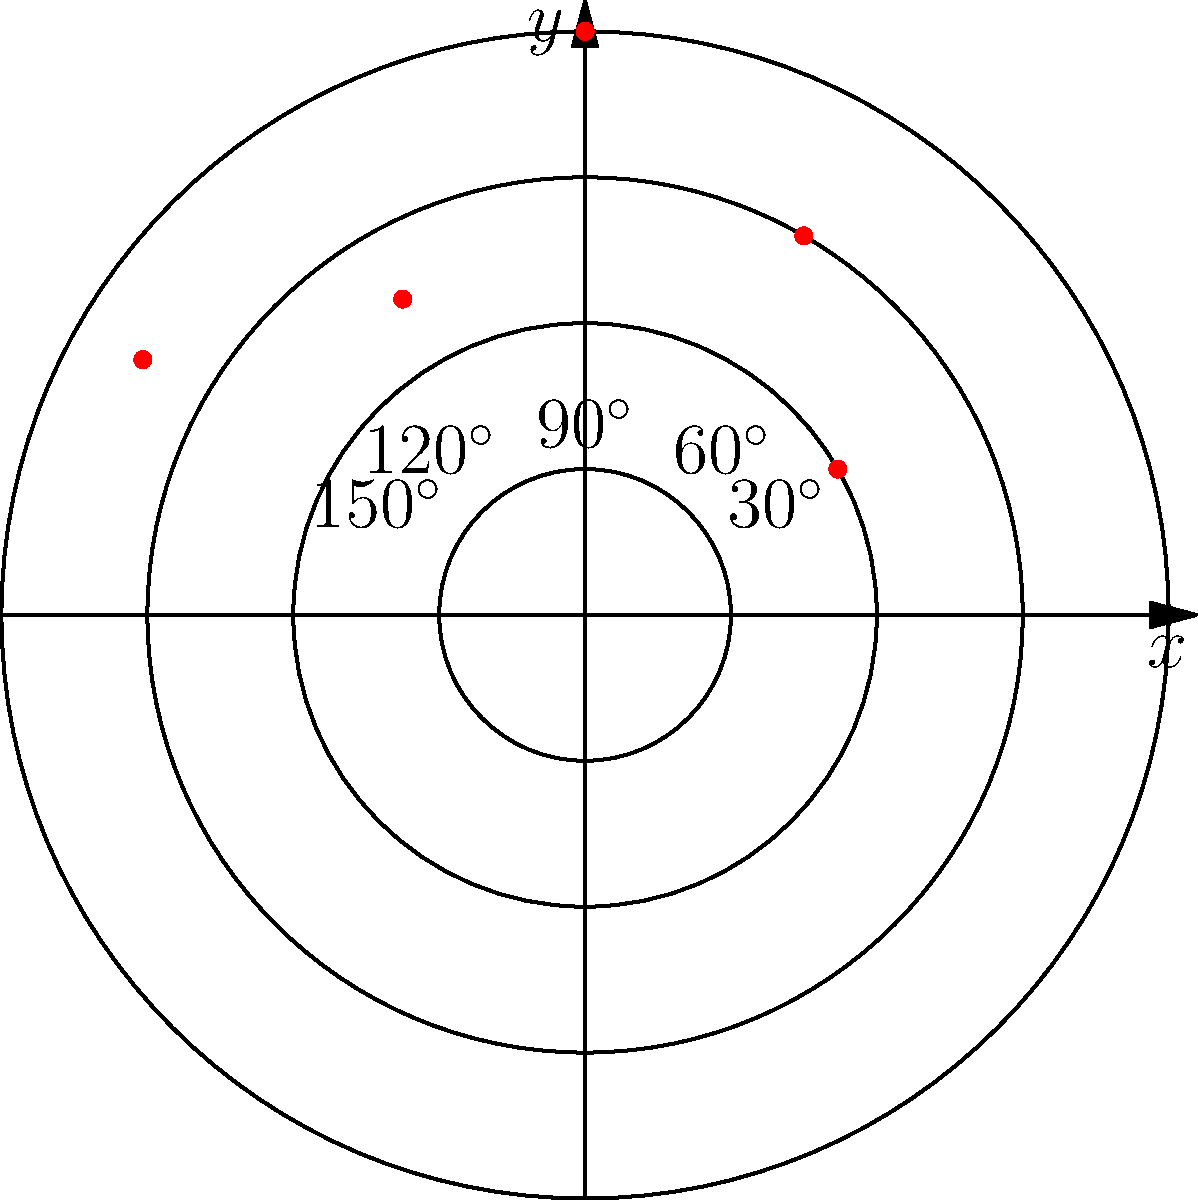In the polar coordinate system shown, five historical buildings are plotted as red dots. The radial grid lines represent distances of 1, 2, 3, and 4 units from the origin. Which quadrant contains the highest concentration of historical buildings, and how many buildings are in that quadrant? To answer this question, we need to analyze the distribution of the red dots (representing historical buildings) in the polar coordinate system:

1. Divide the graph into four quadrants:
   - Quadrant I: 0° to 90°
   - Quadrant II: 90° to 180°
   - Quadrant III: 180° to 270°
   - Quadrant IV: 270° to 360°

2. Count the number of buildings in each quadrant:
   - Quadrant I: 2 buildings (at approximately 30° and 60°)
   - Quadrant II: 3 buildings (at 90°, 120°, and 150°)
   - Quadrant III: 0 buildings
   - Quadrant IV: 0 buildings

3. Identify the quadrant with the highest concentration:
   Quadrant II has the highest concentration with 3 buildings.

Therefore, the quadrant with the highest concentration of historical buildings is Quadrant II, containing 3 buildings.
Answer: Quadrant II, 3 buildings 